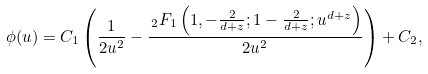<formula> <loc_0><loc_0><loc_500><loc_500>\phi ( u ) = C _ { 1 } \left ( \frac { 1 } { 2 u ^ { 2 } } - \frac { \, _ { 2 } F _ { 1 } \left ( 1 , - \frac { 2 } { d + z } ; 1 - \frac { 2 } { d + z } ; u ^ { d + z } \right ) } { 2 u ^ { 2 } } \right ) + C _ { 2 } ,</formula> 